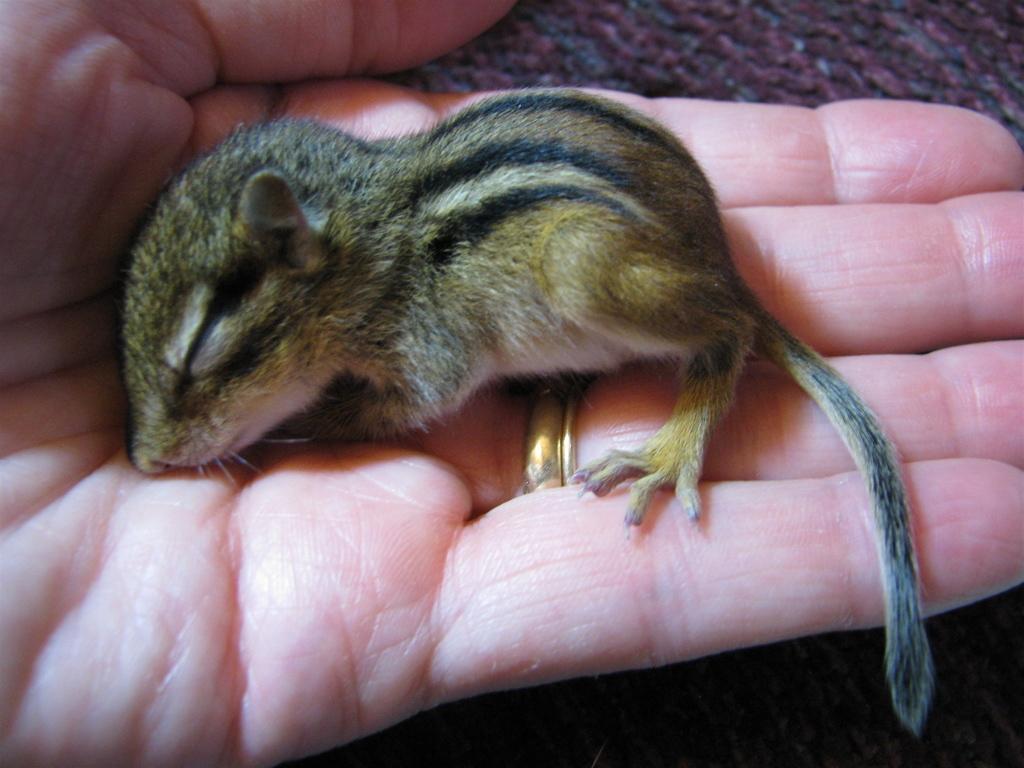Describe this image in one or two sentences. In this picture, we see the hand of the person who is holding the baby squirrel. In the background, it is brown in color. 